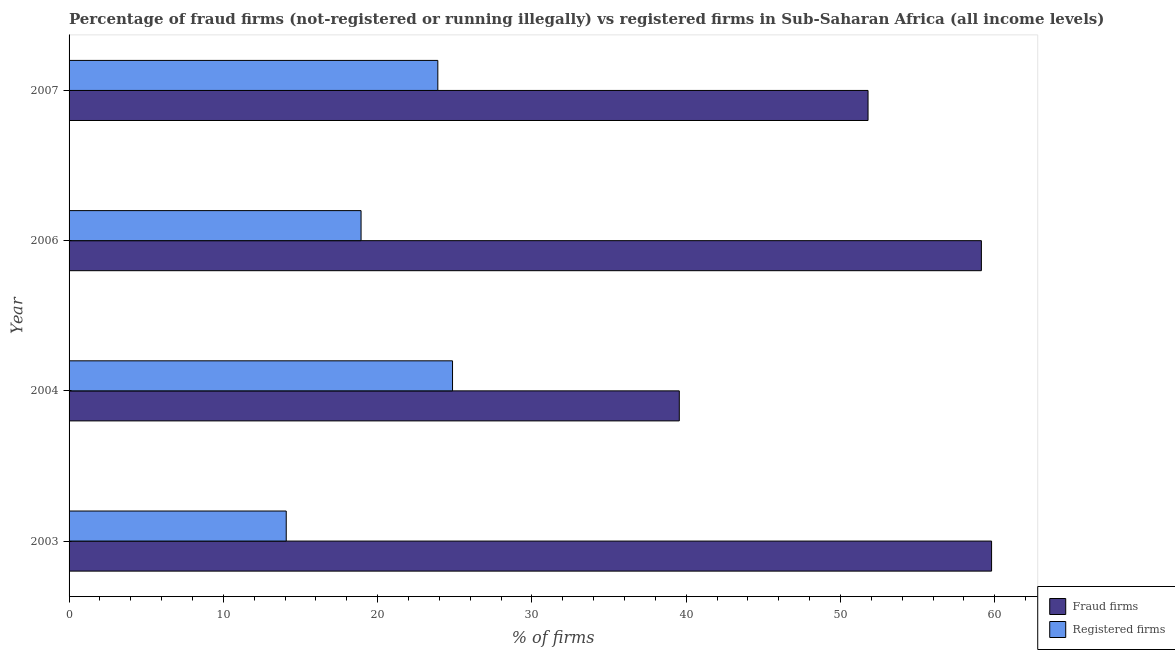How many different coloured bars are there?
Ensure brevity in your answer.  2. Are the number of bars per tick equal to the number of legend labels?
Provide a succinct answer. Yes. How many bars are there on the 4th tick from the bottom?
Offer a terse response. 2. What is the label of the 2nd group of bars from the top?
Make the answer very short. 2006. What is the percentage of registered firms in 2006?
Your answer should be compact. 18.93. Across all years, what is the maximum percentage of fraud firms?
Provide a short and direct response. 59.79. Across all years, what is the minimum percentage of registered firms?
Your response must be concise. 14.07. In which year was the percentage of registered firms maximum?
Your answer should be compact. 2004. What is the total percentage of registered firms in the graph?
Your response must be concise. 81.75. What is the difference between the percentage of fraud firms in 2004 and that in 2007?
Provide a succinct answer. -12.23. What is the difference between the percentage of registered firms in 2003 and the percentage of fraud firms in 2007?
Your answer should be compact. -37.71. What is the average percentage of fraud firms per year?
Ensure brevity in your answer.  52.56. In the year 2006, what is the difference between the percentage of registered firms and percentage of fraud firms?
Your answer should be very brief. -40.2. In how many years, is the percentage of fraud firms greater than 18 %?
Your response must be concise. 4. What is the ratio of the percentage of registered firms in 2003 to that in 2007?
Your answer should be compact. 0.59. Is the percentage of registered firms in 2003 less than that in 2006?
Your answer should be very brief. Yes. What is the difference between the highest and the second highest percentage of fraud firms?
Your answer should be compact. 0.66. What is the difference between the highest and the lowest percentage of fraud firms?
Offer a terse response. 20.24. Is the sum of the percentage of registered firms in 2003 and 2007 greater than the maximum percentage of fraud firms across all years?
Keep it short and to the point. No. What does the 1st bar from the top in 2006 represents?
Keep it short and to the point. Registered firms. What does the 2nd bar from the bottom in 2003 represents?
Make the answer very short. Registered firms. Are all the bars in the graph horizontal?
Provide a short and direct response. Yes. Does the graph contain grids?
Offer a very short reply. No. Where does the legend appear in the graph?
Provide a short and direct response. Bottom right. How are the legend labels stacked?
Your answer should be compact. Vertical. What is the title of the graph?
Give a very brief answer. Percentage of fraud firms (not-registered or running illegally) vs registered firms in Sub-Saharan Africa (all income levels). What is the label or title of the X-axis?
Your answer should be very brief. % of firms. What is the label or title of the Y-axis?
Provide a succinct answer. Year. What is the % of firms in Fraud firms in 2003?
Provide a short and direct response. 59.79. What is the % of firms of Registered firms in 2003?
Your answer should be compact. 14.07. What is the % of firms of Fraud firms in 2004?
Ensure brevity in your answer.  39.55. What is the % of firms in Registered firms in 2004?
Offer a terse response. 24.85. What is the % of firms of Fraud firms in 2006?
Keep it short and to the point. 59.13. What is the % of firms of Registered firms in 2006?
Give a very brief answer. 18.93. What is the % of firms in Fraud firms in 2007?
Offer a terse response. 51.78. What is the % of firms of Registered firms in 2007?
Provide a succinct answer. 23.9. Across all years, what is the maximum % of firms of Fraud firms?
Ensure brevity in your answer.  59.79. Across all years, what is the maximum % of firms in Registered firms?
Provide a succinct answer. 24.85. Across all years, what is the minimum % of firms of Fraud firms?
Offer a very short reply. 39.55. Across all years, what is the minimum % of firms of Registered firms?
Your response must be concise. 14.07. What is the total % of firms of Fraud firms in the graph?
Your answer should be very brief. 210.25. What is the total % of firms in Registered firms in the graph?
Your response must be concise. 81.75. What is the difference between the % of firms in Fraud firms in 2003 and that in 2004?
Give a very brief answer. 20.24. What is the difference between the % of firms of Registered firms in 2003 and that in 2004?
Your answer should be very brief. -10.78. What is the difference between the % of firms in Fraud firms in 2003 and that in 2006?
Your answer should be compact. 0.66. What is the difference between the % of firms of Registered firms in 2003 and that in 2006?
Provide a short and direct response. -4.85. What is the difference between the % of firms of Fraud firms in 2003 and that in 2007?
Your answer should be compact. 8.01. What is the difference between the % of firms of Registered firms in 2003 and that in 2007?
Ensure brevity in your answer.  -9.82. What is the difference between the % of firms in Fraud firms in 2004 and that in 2006?
Give a very brief answer. -19.58. What is the difference between the % of firms in Registered firms in 2004 and that in 2006?
Offer a terse response. 5.93. What is the difference between the % of firms in Fraud firms in 2004 and that in 2007?
Ensure brevity in your answer.  -12.23. What is the difference between the % of firms of Registered firms in 2004 and that in 2007?
Offer a very short reply. 0.95. What is the difference between the % of firms in Fraud firms in 2006 and that in 2007?
Your response must be concise. 7.35. What is the difference between the % of firms in Registered firms in 2006 and that in 2007?
Your answer should be very brief. -4.97. What is the difference between the % of firms of Fraud firms in 2003 and the % of firms of Registered firms in 2004?
Offer a terse response. 34.94. What is the difference between the % of firms of Fraud firms in 2003 and the % of firms of Registered firms in 2006?
Your response must be concise. 40.87. What is the difference between the % of firms of Fraud firms in 2003 and the % of firms of Registered firms in 2007?
Your response must be concise. 35.89. What is the difference between the % of firms in Fraud firms in 2004 and the % of firms in Registered firms in 2006?
Provide a succinct answer. 20.62. What is the difference between the % of firms of Fraud firms in 2004 and the % of firms of Registered firms in 2007?
Your answer should be very brief. 15.65. What is the difference between the % of firms of Fraud firms in 2006 and the % of firms of Registered firms in 2007?
Offer a terse response. 35.23. What is the average % of firms of Fraud firms per year?
Ensure brevity in your answer.  52.56. What is the average % of firms of Registered firms per year?
Provide a succinct answer. 20.44. In the year 2003, what is the difference between the % of firms in Fraud firms and % of firms in Registered firms?
Make the answer very short. 45.72. In the year 2004, what is the difference between the % of firms of Fraud firms and % of firms of Registered firms?
Offer a very short reply. 14.7. In the year 2006, what is the difference between the % of firms in Fraud firms and % of firms in Registered firms?
Make the answer very short. 40.2. In the year 2007, what is the difference between the % of firms in Fraud firms and % of firms in Registered firms?
Provide a succinct answer. 27.88. What is the ratio of the % of firms of Fraud firms in 2003 to that in 2004?
Offer a terse response. 1.51. What is the ratio of the % of firms of Registered firms in 2003 to that in 2004?
Ensure brevity in your answer.  0.57. What is the ratio of the % of firms in Fraud firms in 2003 to that in 2006?
Offer a terse response. 1.01. What is the ratio of the % of firms in Registered firms in 2003 to that in 2006?
Offer a terse response. 0.74. What is the ratio of the % of firms of Fraud firms in 2003 to that in 2007?
Offer a terse response. 1.15. What is the ratio of the % of firms of Registered firms in 2003 to that in 2007?
Provide a short and direct response. 0.59. What is the ratio of the % of firms in Fraud firms in 2004 to that in 2006?
Your response must be concise. 0.67. What is the ratio of the % of firms in Registered firms in 2004 to that in 2006?
Keep it short and to the point. 1.31. What is the ratio of the % of firms in Fraud firms in 2004 to that in 2007?
Keep it short and to the point. 0.76. What is the ratio of the % of firms in Registered firms in 2004 to that in 2007?
Provide a short and direct response. 1.04. What is the ratio of the % of firms of Fraud firms in 2006 to that in 2007?
Your answer should be very brief. 1.14. What is the ratio of the % of firms in Registered firms in 2006 to that in 2007?
Your answer should be compact. 0.79. What is the difference between the highest and the second highest % of firms of Fraud firms?
Ensure brevity in your answer.  0.66. What is the difference between the highest and the second highest % of firms of Registered firms?
Provide a short and direct response. 0.95. What is the difference between the highest and the lowest % of firms of Fraud firms?
Your answer should be compact. 20.24. What is the difference between the highest and the lowest % of firms in Registered firms?
Keep it short and to the point. 10.78. 